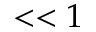<formula> <loc_0><loc_0><loc_500><loc_500>< < 1</formula> 